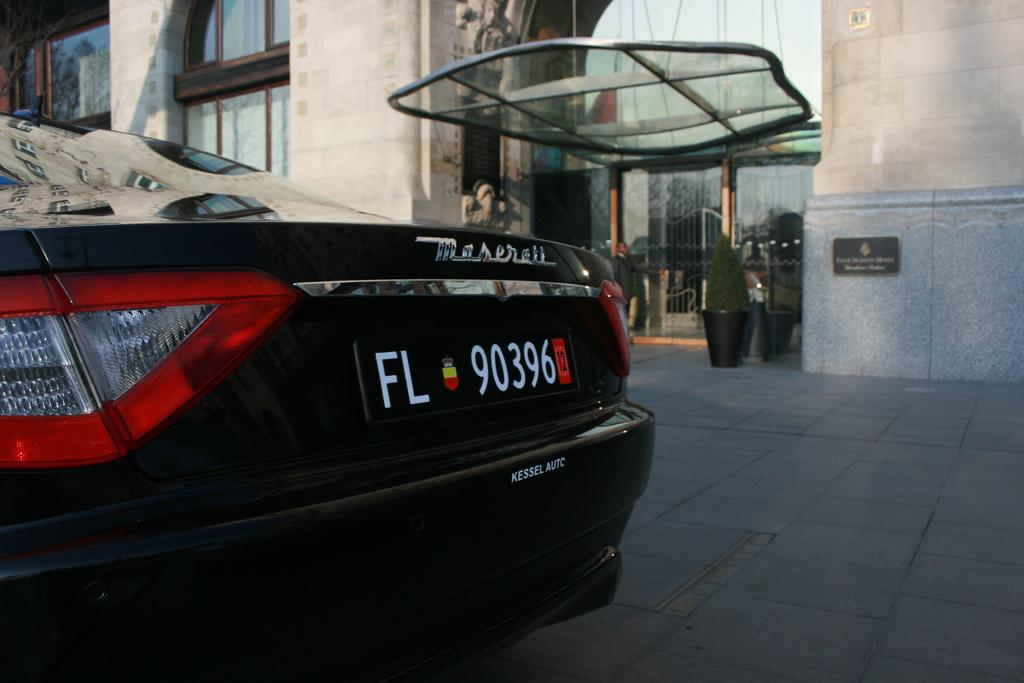What is the main subject of the image? There is a car on the road in the image. What can be seen in the background of the image? There are buildings in the background of the image. Is there any vegetation visible in the image? Yes, there is a plant visible in the image. Can you see a hose being used to water the plant in the image? There is no hose visible in the image. Is anyone seen kicking the car in the image? No one is seen kicking the car in the image. 